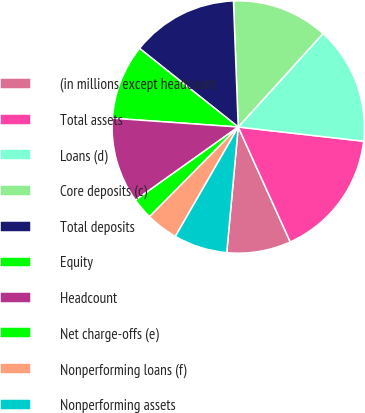<chart> <loc_0><loc_0><loc_500><loc_500><pie_chart><fcel>(in millions except headcount<fcel>Total assets<fcel>Loans (d)<fcel>Core deposits (c)<fcel>Total deposits<fcel>Equity<fcel>Headcount<fcel>Net charge-offs (e)<fcel>Nonperforming loans (f)<fcel>Nonperforming assets<nl><fcel>8.22%<fcel>16.44%<fcel>15.07%<fcel>12.33%<fcel>13.7%<fcel>9.59%<fcel>10.96%<fcel>2.74%<fcel>4.11%<fcel>6.85%<nl></chart> 